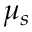Convert formula to latex. <formula><loc_0><loc_0><loc_500><loc_500>\mu _ { s }</formula> 